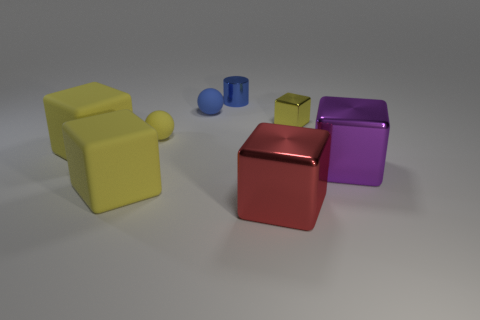Add 1 spheres. How many objects exist? 9 Subtract all yellow matte blocks. How many blocks are left? 3 Subtract all yellow blocks. How many blocks are left? 2 Subtract all yellow cubes. How many yellow balls are left? 1 Subtract all purple objects. Subtract all small blue rubber things. How many objects are left? 6 Add 3 big matte objects. How many big matte objects are left? 5 Add 4 large red metal things. How many large red metal things exist? 5 Subtract 0 purple balls. How many objects are left? 8 Subtract all spheres. How many objects are left? 6 Subtract 3 cubes. How many cubes are left? 2 